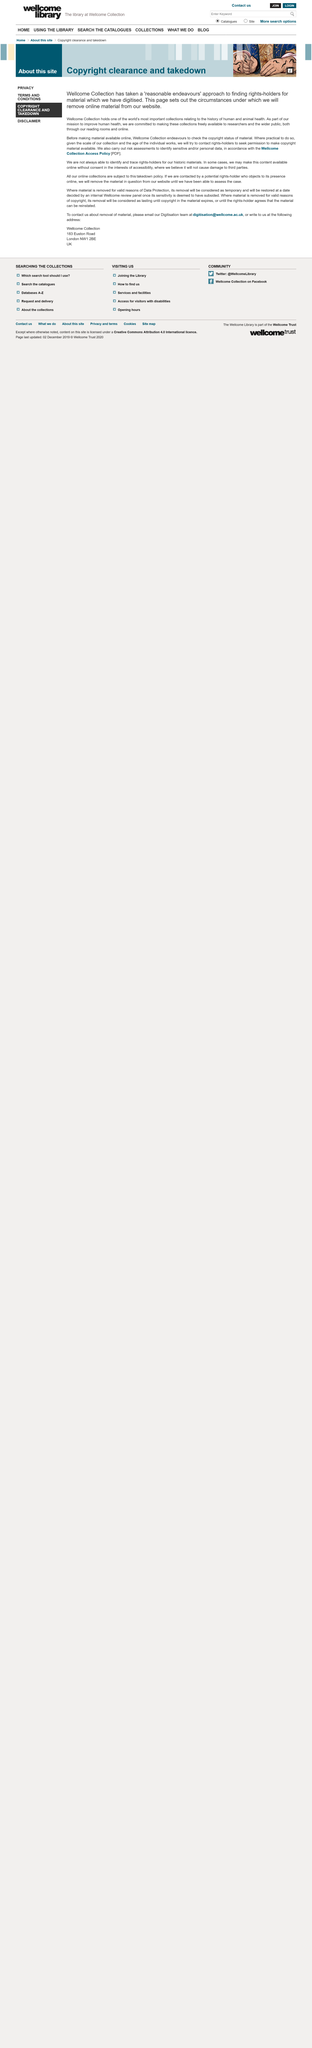Specify some key components in this picture. Wellcome Collection conducts risk assessments before releasing items from its collection to identify sensitive or personal data. Wellcome Collection is attempting to make their collections freely available to improve human health and research. Wellcome Collection is taking a 'reasonable endeavours' approach to finding rights-holders for digitised material in order to make the collections freely available to researchers and the public. 